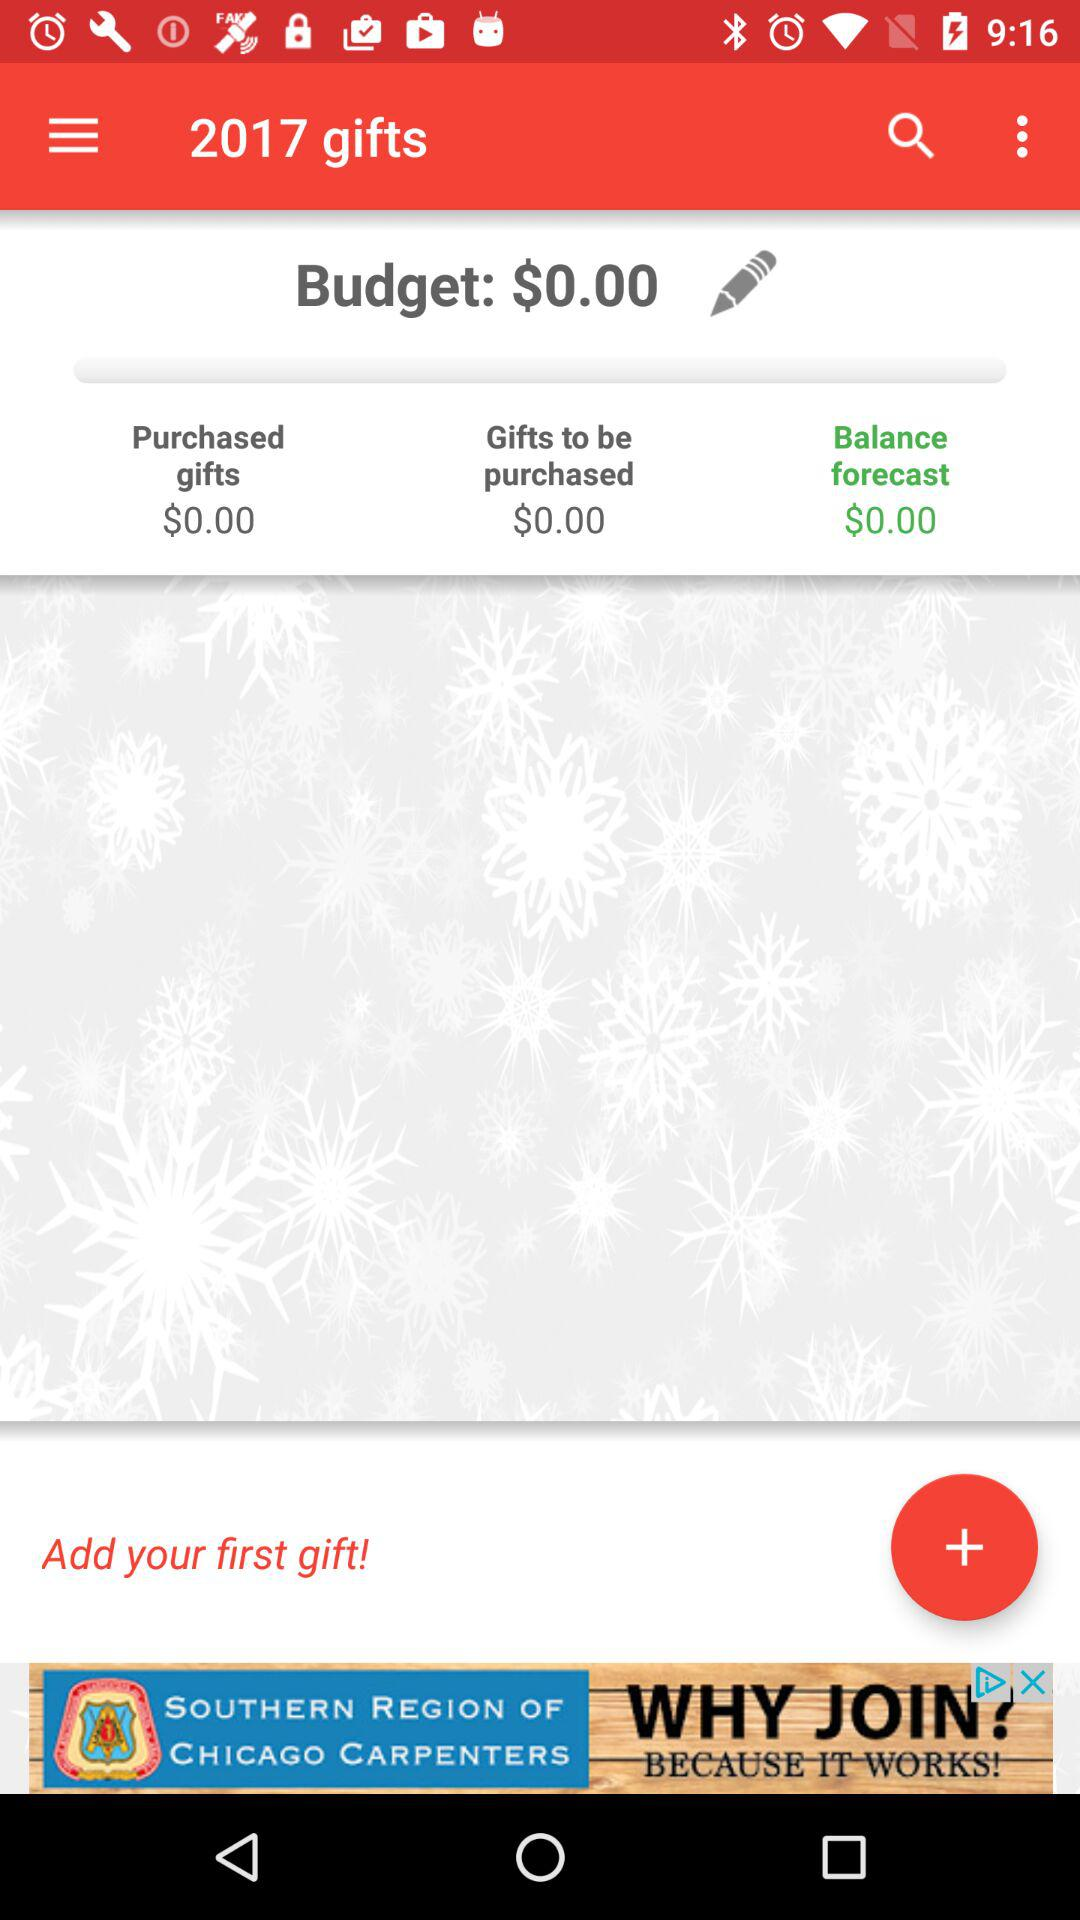What is the amount of purchased gifts? The amount of purchased gifts is $0. 